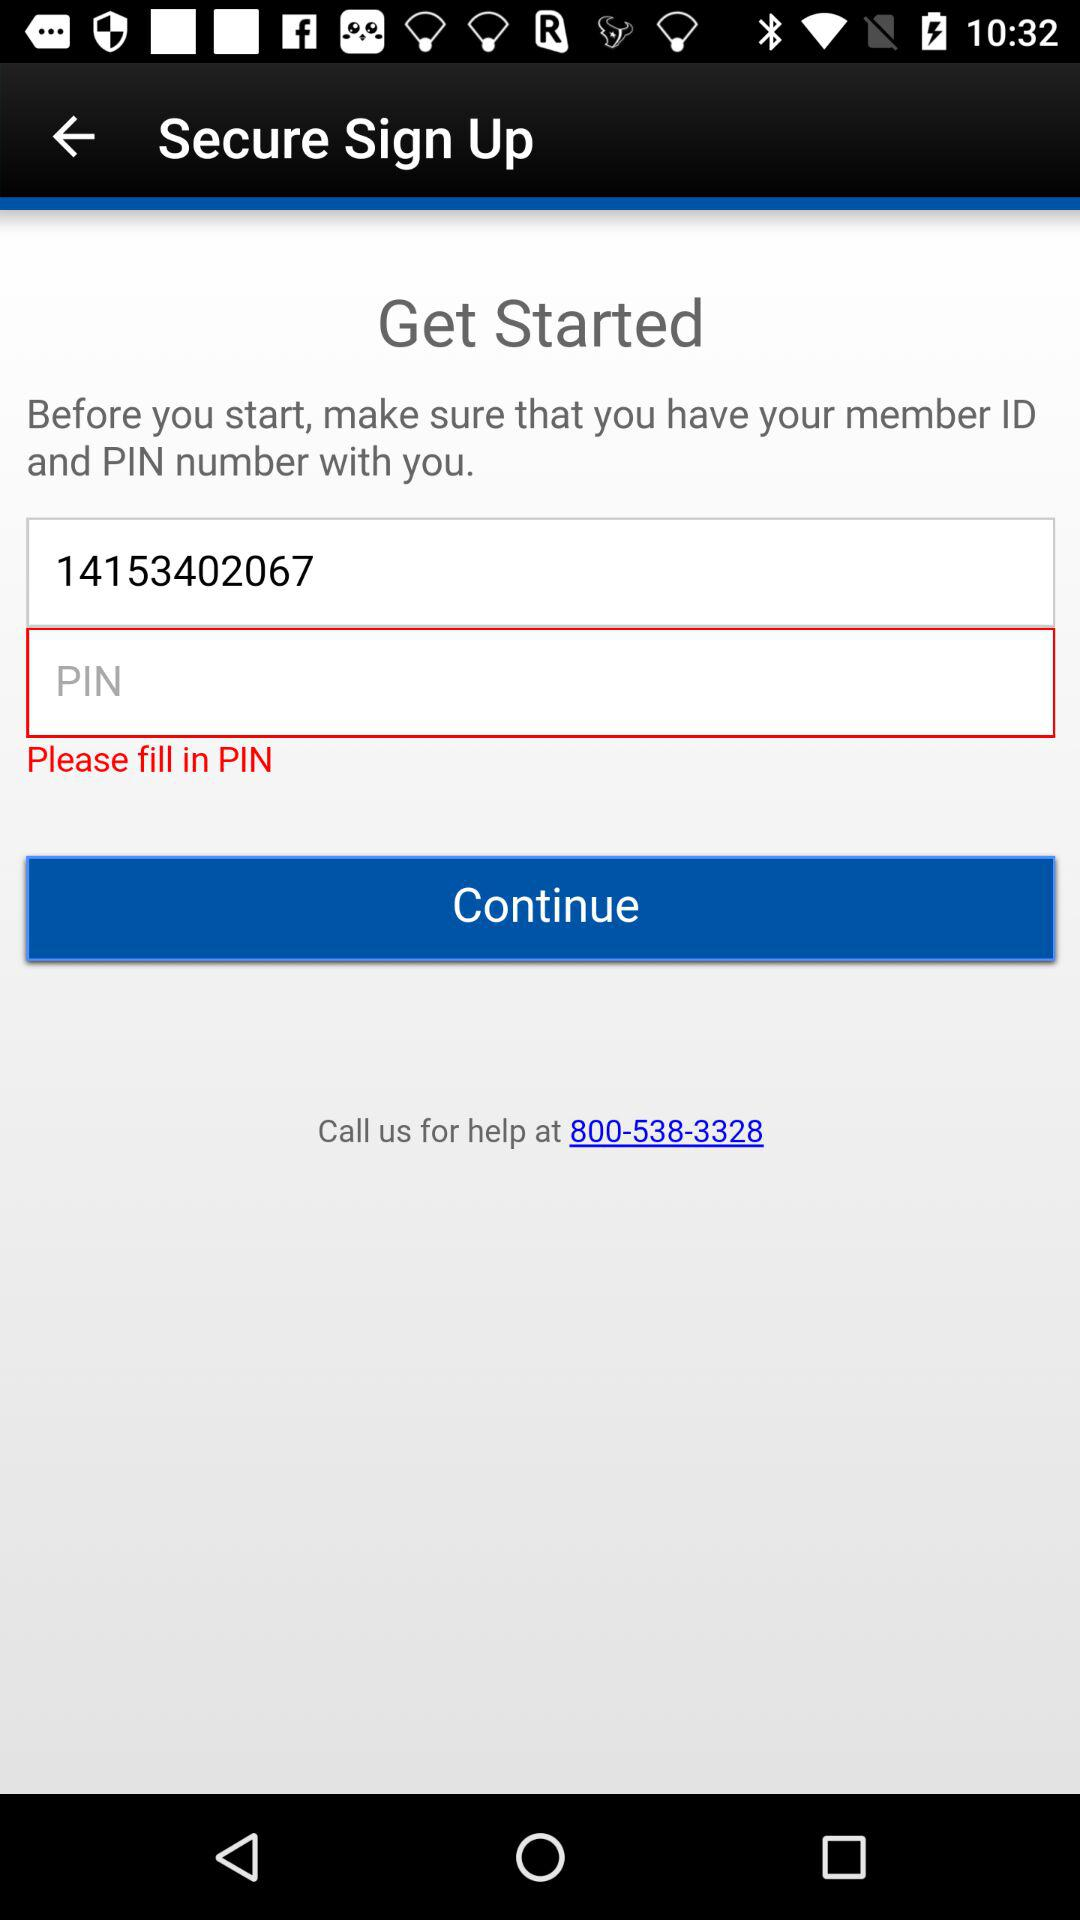How many text inputs are required on this screen?
Answer the question using a single word or phrase. 2 